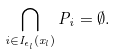Convert formula to latex. <formula><loc_0><loc_0><loc_500><loc_500>\bigcap _ { i \in I _ { \epsilon _ { l } } ( x _ { l } ) } P _ { i } = \emptyset .</formula> 